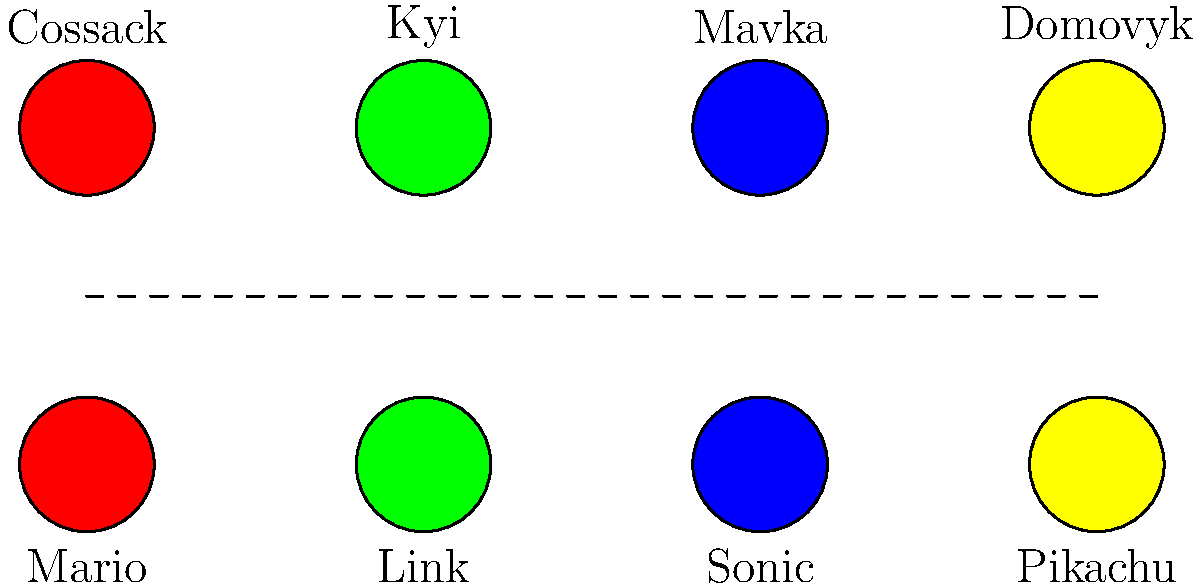Match the video game characters to their Ukrainian folklore counterparts based on their attributes and roles. Which pairing is correct? 1. Mario (Red): A plumber and hero, similar to Cossacks who were defenders of Ukraine.
2. Link (Green): A legendary hero, comparable to Kyi, the legendary founder of Kyiv.
3. Sonic (Blue): A fast, nature-associated character, similar to Mavka, a forest nymph in Ukrainian folklore.
4. Pikachu (Yellow): A small, magical creature, reminiscent of Domovyk, a household spirit in Ukrainian mythology.

The correct pairings are:
- Mario - Cossack
- Link - Kyi
- Sonic - Mavka
- Pikachu - Domovyk

These pairings are based on shared characteristics and roles in their respective contexts.
Answer: Mario-Cossack, Link-Kyi, Sonic-Mavka, Pikachu-Domovyk 